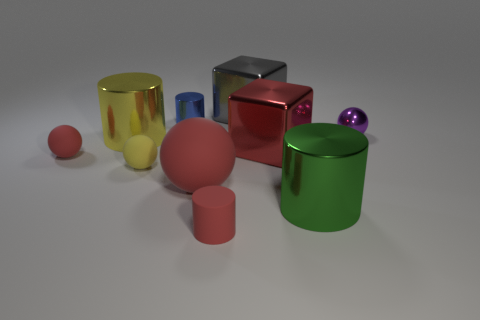There is a yellow sphere; how many large green metal cylinders are on the right side of it?
Ensure brevity in your answer.  1. Are there any yellow rubber objects that have the same size as the yellow rubber ball?
Provide a short and direct response. No. There is a metallic thing that is behind the blue object; does it have the same shape as the small purple shiny object?
Your answer should be very brief. No. The shiny ball is what color?
Provide a short and direct response. Purple. There is a small thing that is the same color as the tiny matte cylinder; what is its shape?
Your answer should be very brief. Sphere. Are there any small blue matte objects?
Keep it short and to the point. No. There is a blue cylinder that is the same material as the big gray block; what size is it?
Your answer should be compact. Small. What is the shape of the tiny shiny object to the left of the small red thing on the right side of the tiny red object that is to the left of the small blue shiny object?
Provide a short and direct response. Cylinder. Are there the same number of small blue cylinders in front of the tiny purple shiny ball and big gray metal spheres?
Your answer should be very brief. Yes. There is a cube that is the same color as the large matte object; what is its size?
Make the answer very short. Large. 